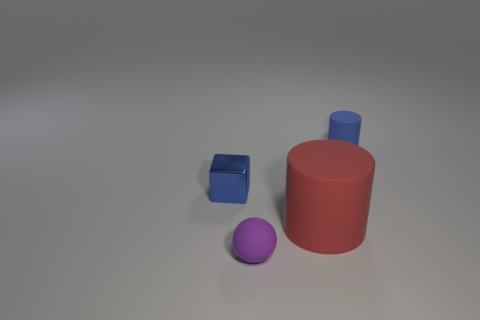What is the color of the thing left of the tiny rubber ball right of the tiny object that is on the left side of the tiny purple matte sphere?
Make the answer very short. Blue. How many other things are the same shape as the metal thing?
Provide a succinct answer. 0. There is a rubber object that is to the left of the large thing; what is its shape?
Your answer should be very brief. Sphere. There is a thing to the right of the large rubber object; is there a red matte thing right of it?
Offer a very short reply. No. What color is the object that is on the right side of the small blue block and behind the red cylinder?
Provide a succinct answer. Blue. Is there a tiny blue cube in front of the cylinder that is to the right of the big red thing on the right side of the tiny purple matte ball?
Provide a short and direct response. Yes. The other matte object that is the same shape as the red thing is what size?
Keep it short and to the point. Small. Is there any other thing that has the same material as the red object?
Make the answer very short. Yes. Are there any purple objects?
Your answer should be very brief. Yes. There is a small matte sphere; is it the same color as the matte cylinder that is behind the big red cylinder?
Make the answer very short. No. 